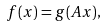<formula> <loc_0><loc_0><loc_500><loc_500>f ( x ) = g ( A x ) ,</formula> 